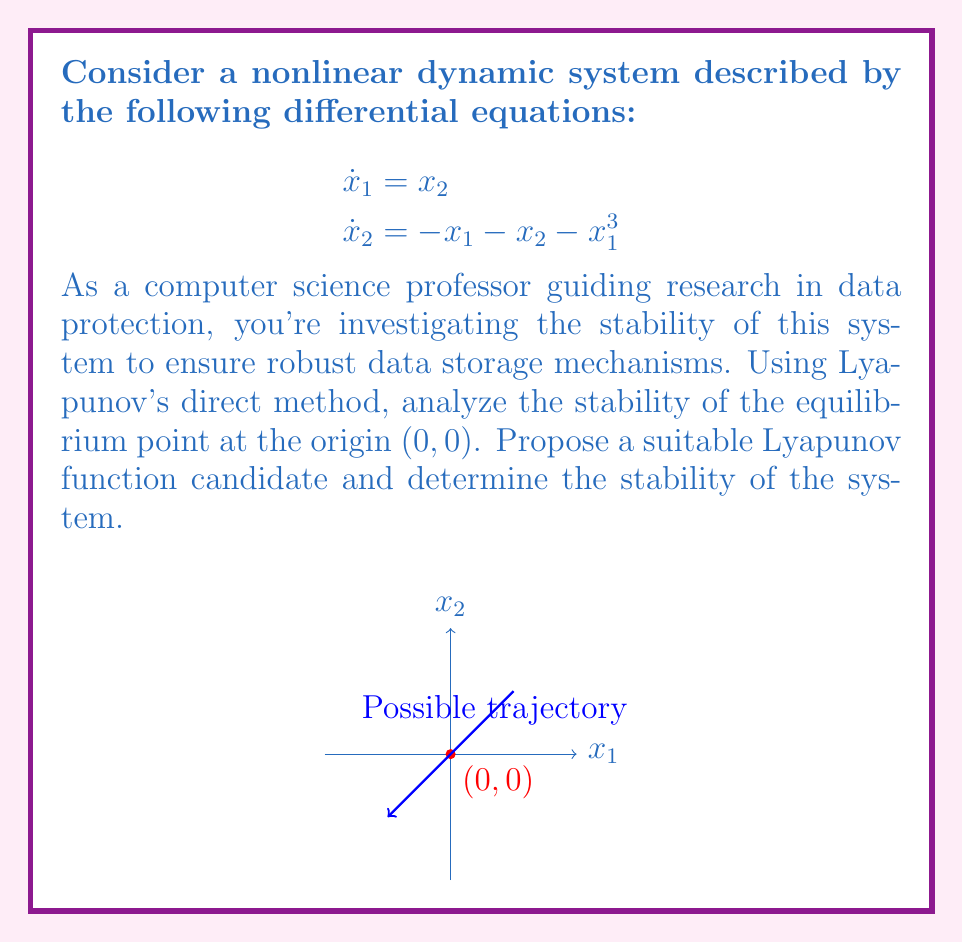Solve this math problem. To analyze the stability of the nonlinear system using Lyapunov's direct method, we'll follow these steps:

1) First, we need to choose a Lyapunov function candidate. Given the structure of the system, a suitable candidate is:

   $$V(x_1, x_2) = \frac{1}{2}x_1^2 + \frac{1}{2}x_2^2 + \frac{1}{4}x_1^4$$

   This function is positive definite and radially unbounded.

2) Now, we need to calculate the time derivative of V along the system trajectories:

   $$\begin{aligned}
   \dot{V} &= \frac{\partial V}{\partial x_1}\dot{x}_1 + \frac{\partial V}{\partial x_2}\dot{x}_2 \\
   &= (x_1 + x_1^3)x_2 + x_2(-x_1 - x_2 - x_1^3) \\
   &= x_1x_2 + x_1^3x_2 - x_1x_2 - x_2^2 - x_1^3x_2 \\
   &= -x_2^2
   \end{aligned}$$

3) Analyze $\dot{V}$:
   - $\dot{V}$ is negative semi-definite (it's always non-positive for all $x_1$ and $x_2$).
   - $\dot{V} = 0$ when $x_2 = 0$, but this doesn't imply that $x_1 = 0$.

4) Since $\dot{V}$ is only negative semi-definite, we can't conclude asymptotic stability directly. We need to use LaSalle's Invariance Principle:

   - The set where $\dot{V} = 0$ is $E = \{(x_1, x_2) | x_2 = 0\}$.
   - In this set, the system dynamics reduce to:
     $$\begin{aligned}
     \dot{x}_1 &= 0 \\
     \dot{x}_2 &= -x_1 - x_1^3
     \end{aligned}$$
   - The only invariant set within E is the origin (0,0).

5) By LaSalle's Invariance Principle, all solutions converge to the origin as $t \to \infty$.

Therefore, we can conclude that the origin is globally asymptotically stable.
Answer: The origin (0,0) is globally asymptotically stable. 